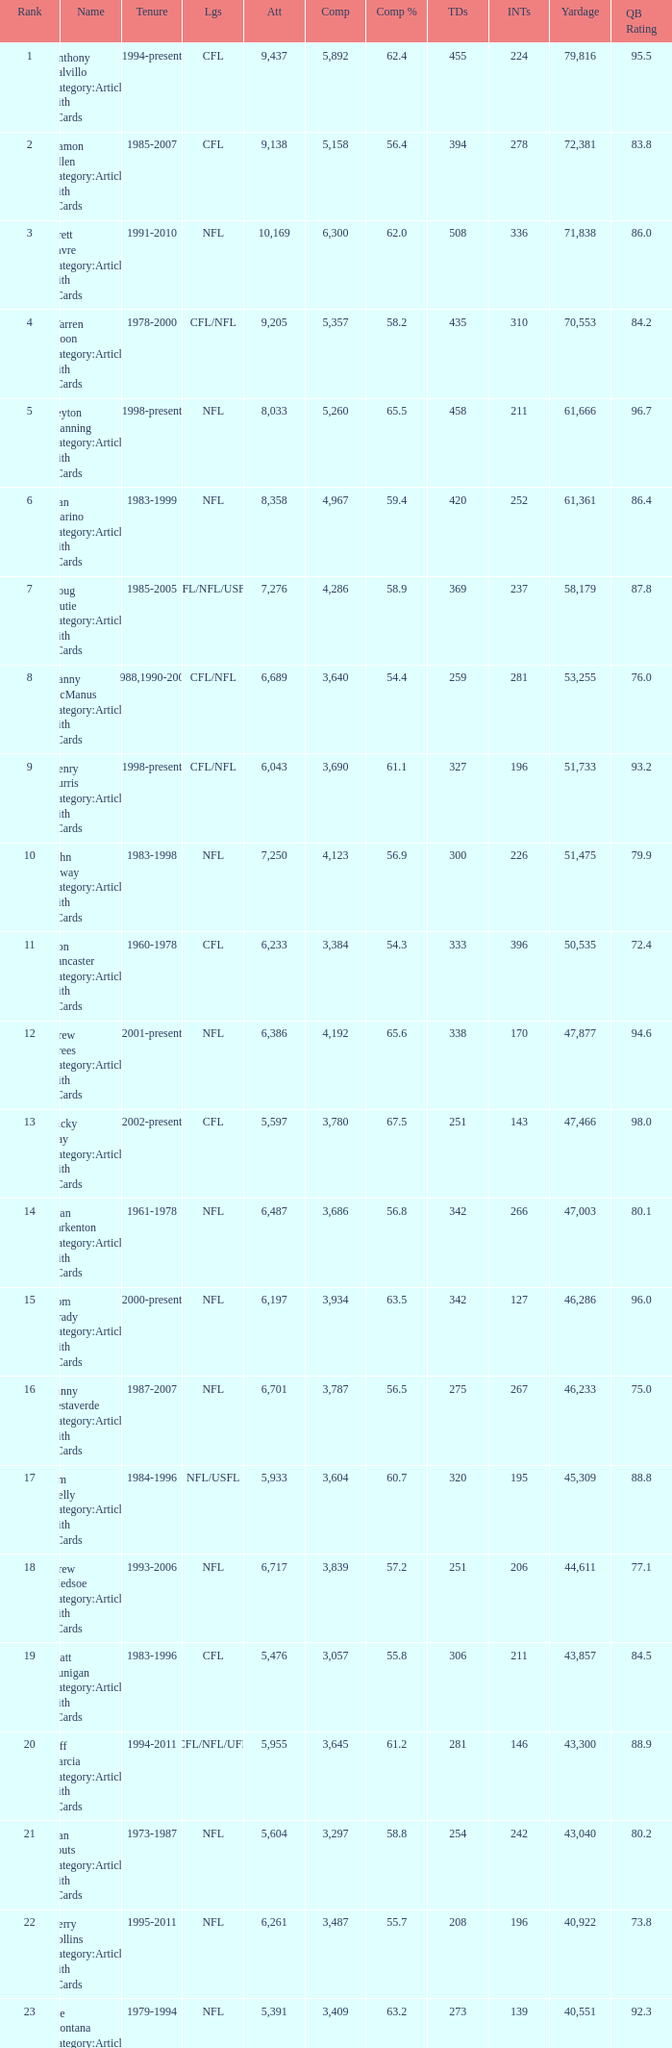What is the rank when there are more than 4,123 completion and the comp percentage is more than 65.6? None. I'm looking to parse the entire table for insights. Could you assist me with that? {'header': ['Rank', 'Name', 'Tenure', 'Lgs', 'Att', 'Comp', 'Comp %', 'TDs', 'INTs', 'Yardage', 'QB Rating'], 'rows': [['1', 'Anthony Calvillo Category:Articles with hCards', '1994-present', 'CFL', '9,437', '5,892', '62.4', '455', '224', '79,816', '95.5'], ['2', 'Damon Allen Category:Articles with hCards', '1985-2007', 'CFL', '9,138', '5,158', '56.4', '394', '278', '72,381', '83.8'], ['3', 'Brett Favre Category:Articles with hCards', '1991-2010', 'NFL', '10,169', '6,300', '62.0', '508', '336', '71,838', '86.0'], ['4', 'Warren Moon Category:Articles with hCards', '1978-2000', 'CFL/NFL', '9,205', '5,357', '58.2', '435', '310', '70,553', '84.2'], ['5', 'Peyton Manning Category:Articles with hCards', '1998-present', 'NFL', '8,033', '5,260', '65.5', '458', '211', '61,666', '96.7'], ['6', 'Dan Marino Category:Articles with hCards', '1983-1999', 'NFL', '8,358', '4,967', '59.4', '420', '252', '61,361', '86.4'], ['7', 'Doug Flutie Category:Articles with hCards', '1985-2005', 'CFL/NFL/USFL', '7,276', '4,286', '58.9', '369', '237', '58,179', '87.8'], ['8', 'Danny McManus Category:Articles with hCards', '1988,1990-2006', 'CFL/NFL', '6,689', '3,640', '54.4', '259', '281', '53,255', '76.0'], ['9', 'Henry Burris Category:Articles with hCards', '1998-present', 'CFL/NFL', '6,043', '3,690', '61.1', '327', '196', '51,733', '93.2'], ['10', 'John Elway Category:Articles with hCards', '1983-1998', 'NFL', '7,250', '4,123', '56.9', '300', '226', '51,475', '79.9'], ['11', 'Ron Lancaster Category:Articles with hCards', '1960-1978', 'CFL', '6,233', '3,384', '54.3', '333', '396', '50,535', '72.4'], ['12', 'Drew Brees Category:Articles with hCards', '2001-present', 'NFL', '6,386', '4,192', '65.6', '338', '170', '47,877', '94.6'], ['13', 'Ricky Ray Category:Articles with hCards', '2002-present', 'CFL', '5,597', '3,780', '67.5', '251', '143', '47,466', '98.0'], ['14', 'Fran Tarkenton Category:Articles with hCards', '1961-1978', 'NFL', '6,487', '3,686', '56.8', '342', '266', '47,003', '80.1'], ['15', 'Tom Brady Category:Articles with hCards', '2000-present', 'NFL', '6,197', '3,934', '63.5', '342', '127', '46,286', '96.0'], ['16', 'Vinny Testaverde Category:Articles with hCards', '1987-2007', 'NFL', '6,701', '3,787', '56.5', '275', '267', '46,233', '75.0'], ['17', 'Jim Kelly Category:Articles with hCards', '1984-1996', 'NFL/USFL', '5,933', '3,604', '60.7', '320', '195', '45,309', '88.8'], ['18', 'Drew Bledsoe Category:Articles with hCards', '1993-2006', 'NFL', '6,717', '3,839', '57.2', '251', '206', '44,611', '77.1'], ['19', 'Matt Dunigan Category:Articles with hCards', '1983-1996', 'CFL', '5,476', '3,057', '55.8', '306', '211', '43,857', '84.5'], ['20', 'Jeff Garcia Category:Articles with hCards', '1994-2011', 'CFL/NFL/UFL', '5,955', '3,645', '61.2', '281', '146', '43,300', '88.9'], ['21', 'Dan Fouts Category:Articles with hCards', '1973-1987', 'NFL', '5,604', '3,297', '58.8', '254', '242', '43,040', '80.2'], ['22', 'Kerry Collins Category:Articles with hCards', '1995-2011', 'NFL', '6,261', '3,487', '55.7', '208', '196', '40,922', '73.8'], ['23', 'Joe Montana Category:Articles with hCards', '1979-1994', 'NFL', '5,391', '3,409', '63.2', '273', '139', '40,551', '92.3'], ['24', 'Tracy Ham Category:Articles with hCards', '1987-1999', 'CFL', '4,945', '2,670', '54.0', '284', '164', '40,534', '86.6'], ['25', 'Johnny Unitas Category:Articles with hCards', '1956-1973', 'NFL', '5,186', '2,830', '54.6', '290', '253', '40,239', '78.2']]} 